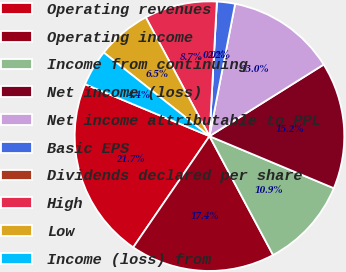Convert chart. <chart><loc_0><loc_0><loc_500><loc_500><pie_chart><fcel>Operating revenues<fcel>Operating income<fcel>Income from continuing<fcel>Net income (loss)<fcel>Net income attributable to PPL<fcel>Basic EPS<fcel>Dividends declared per share<fcel>High<fcel>Low<fcel>Income (loss) from<nl><fcel>21.73%<fcel>17.39%<fcel>10.87%<fcel>15.22%<fcel>13.04%<fcel>2.18%<fcel>0.0%<fcel>8.7%<fcel>6.52%<fcel>4.35%<nl></chart> 